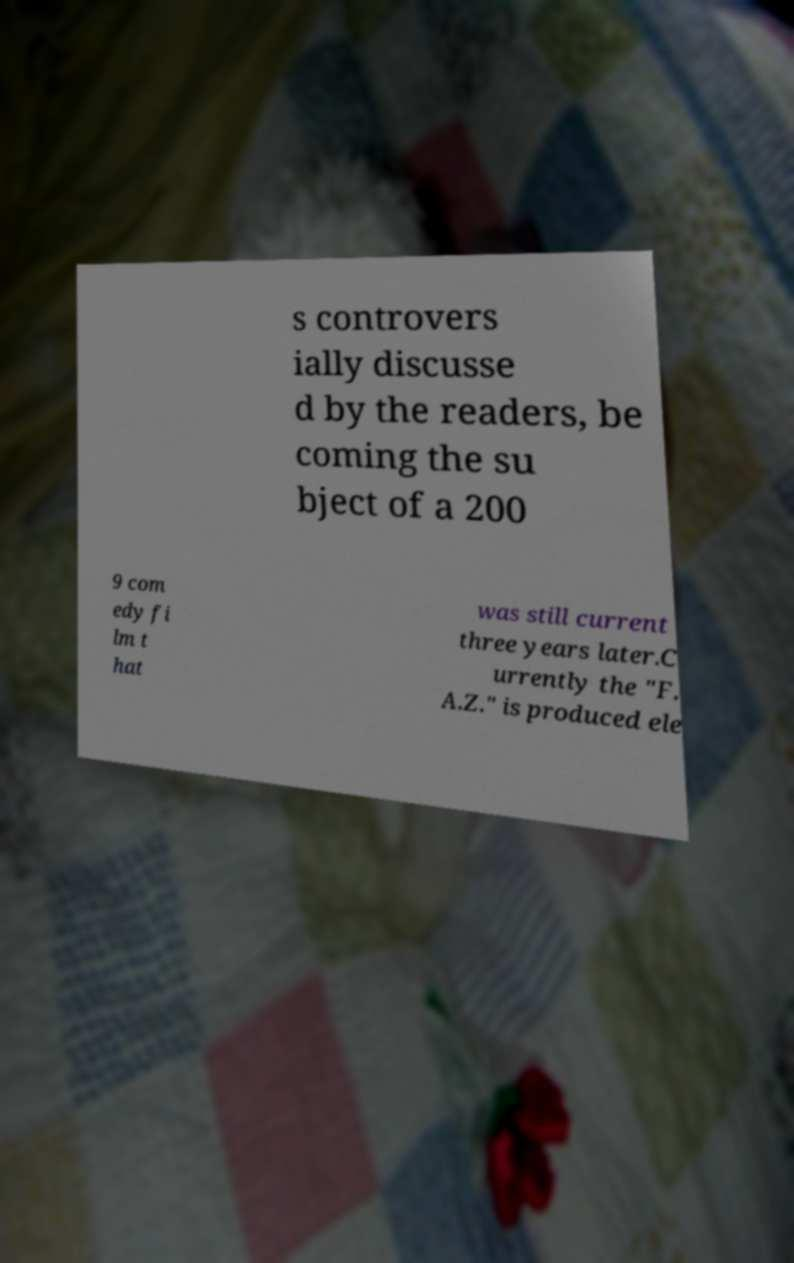Please read and relay the text visible in this image. What does it say? s controvers ially discusse d by the readers, be coming the su bject of a 200 9 com edy fi lm t hat was still current three years later.C urrently the "F. A.Z." is produced ele 